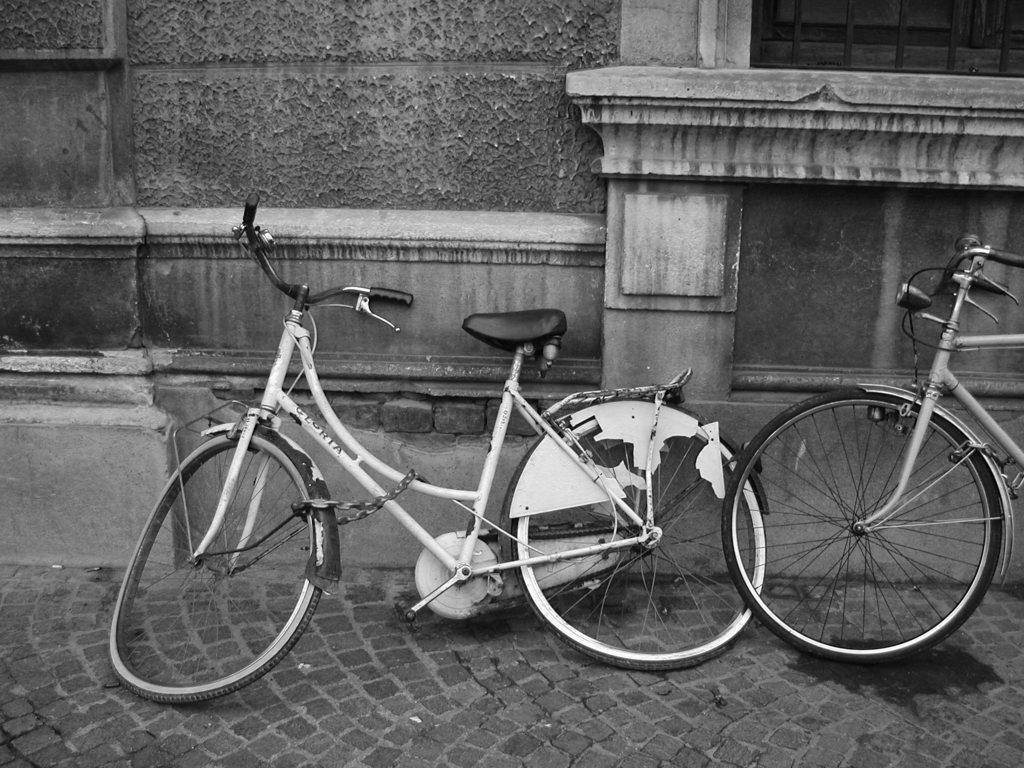Describe this image in one or two sentences. In this image, we can see bicycles on the road and in the background, there is wall. 